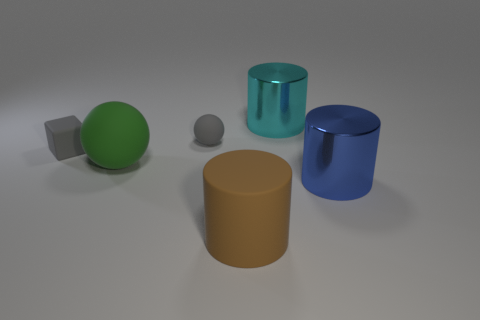Subtract all big brown cylinders. How many cylinders are left? 2 Add 4 large cyan shiny things. How many objects exist? 10 Subtract 1 cylinders. How many cylinders are left? 2 Subtract all brown cylinders. How many cylinders are left? 2 Subtract all purple cylinders. Subtract all purple cubes. How many cylinders are left? 3 Subtract all cubes. How many objects are left? 5 Subtract all gray blocks. Subtract all large green matte balls. How many objects are left? 4 Add 1 small gray balls. How many small gray balls are left? 2 Add 6 blue shiny cylinders. How many blue shiny cylinders exist? 7 Subtract 0 red spheres. How many objects are left? 6 